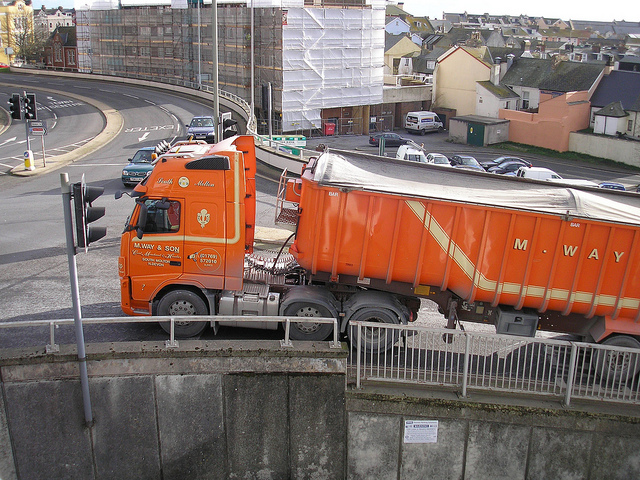Read all the text in this image. M WAY LAWAY 